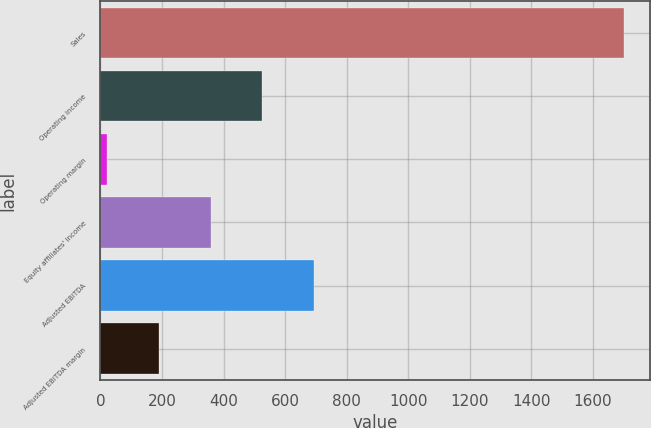Convert chart. <chart><loc_0><loc_0><loc_500><loc_500><bar_chart><fcel>Sales<fcel>Operating income<fcel>Operating margin<fcel>Equity affiliates' income<fcel>Adjusted EBITDA<fcel>Adjusted EBITDA margin<nl><fcel>1700.3<fcel>525.84<fcel>22.5<fcel>358.06<fcel>693.62<fcel>190.28<nl></chart> 